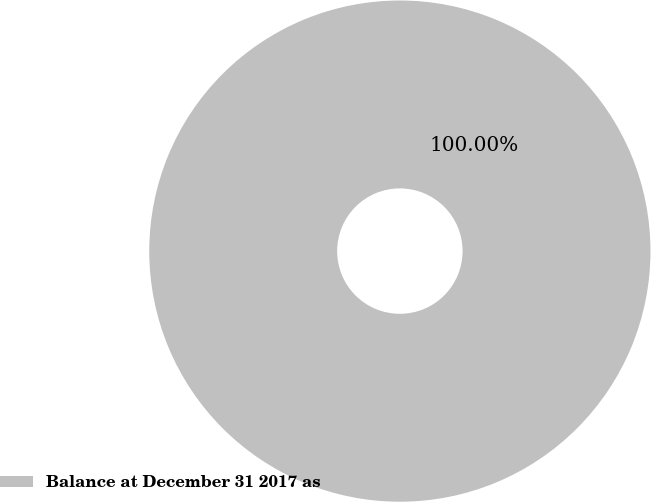Convert chart. <chart><loc_0><loc_0><loc_500><loc_500><pie_chart><fcel>Balance at December 31 2017 as<nl><fcel>100.0%<nl></chart> 